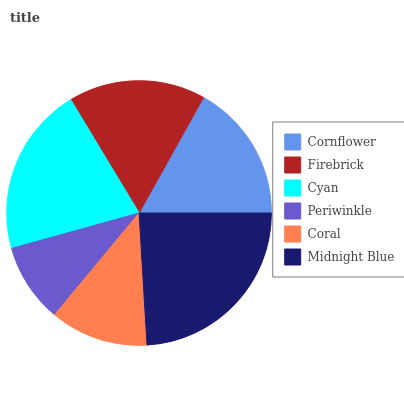Is Periwinkle the minimum?
Answer yes or no. Yes. Is Midnight Blue the maximum?
Answer yes or no. Yes. Is Firebrick the minimum?
Answer yes or no. No. Is Firebrick the maximum?
Answer yes or no. No. Is Cornflower greater than Firebrick?
Answer yes or no. Yes. Is Firebrick less than Cornflower?
Answer yes or no. Yes. Is Firebrick greater than Cornflower?
Answer yes or no. No. Is Cornflower less than Firebrick?
Answer yes or no. No. Is Cornflower the high median?
Answer yes or no. Yes. Is Firebrick the low median?
Answer yes or no. Yes. Is Midnight Blue the high median?
Answer yes or no. No. Is Coral the low median?
Answer yes or no. No. 